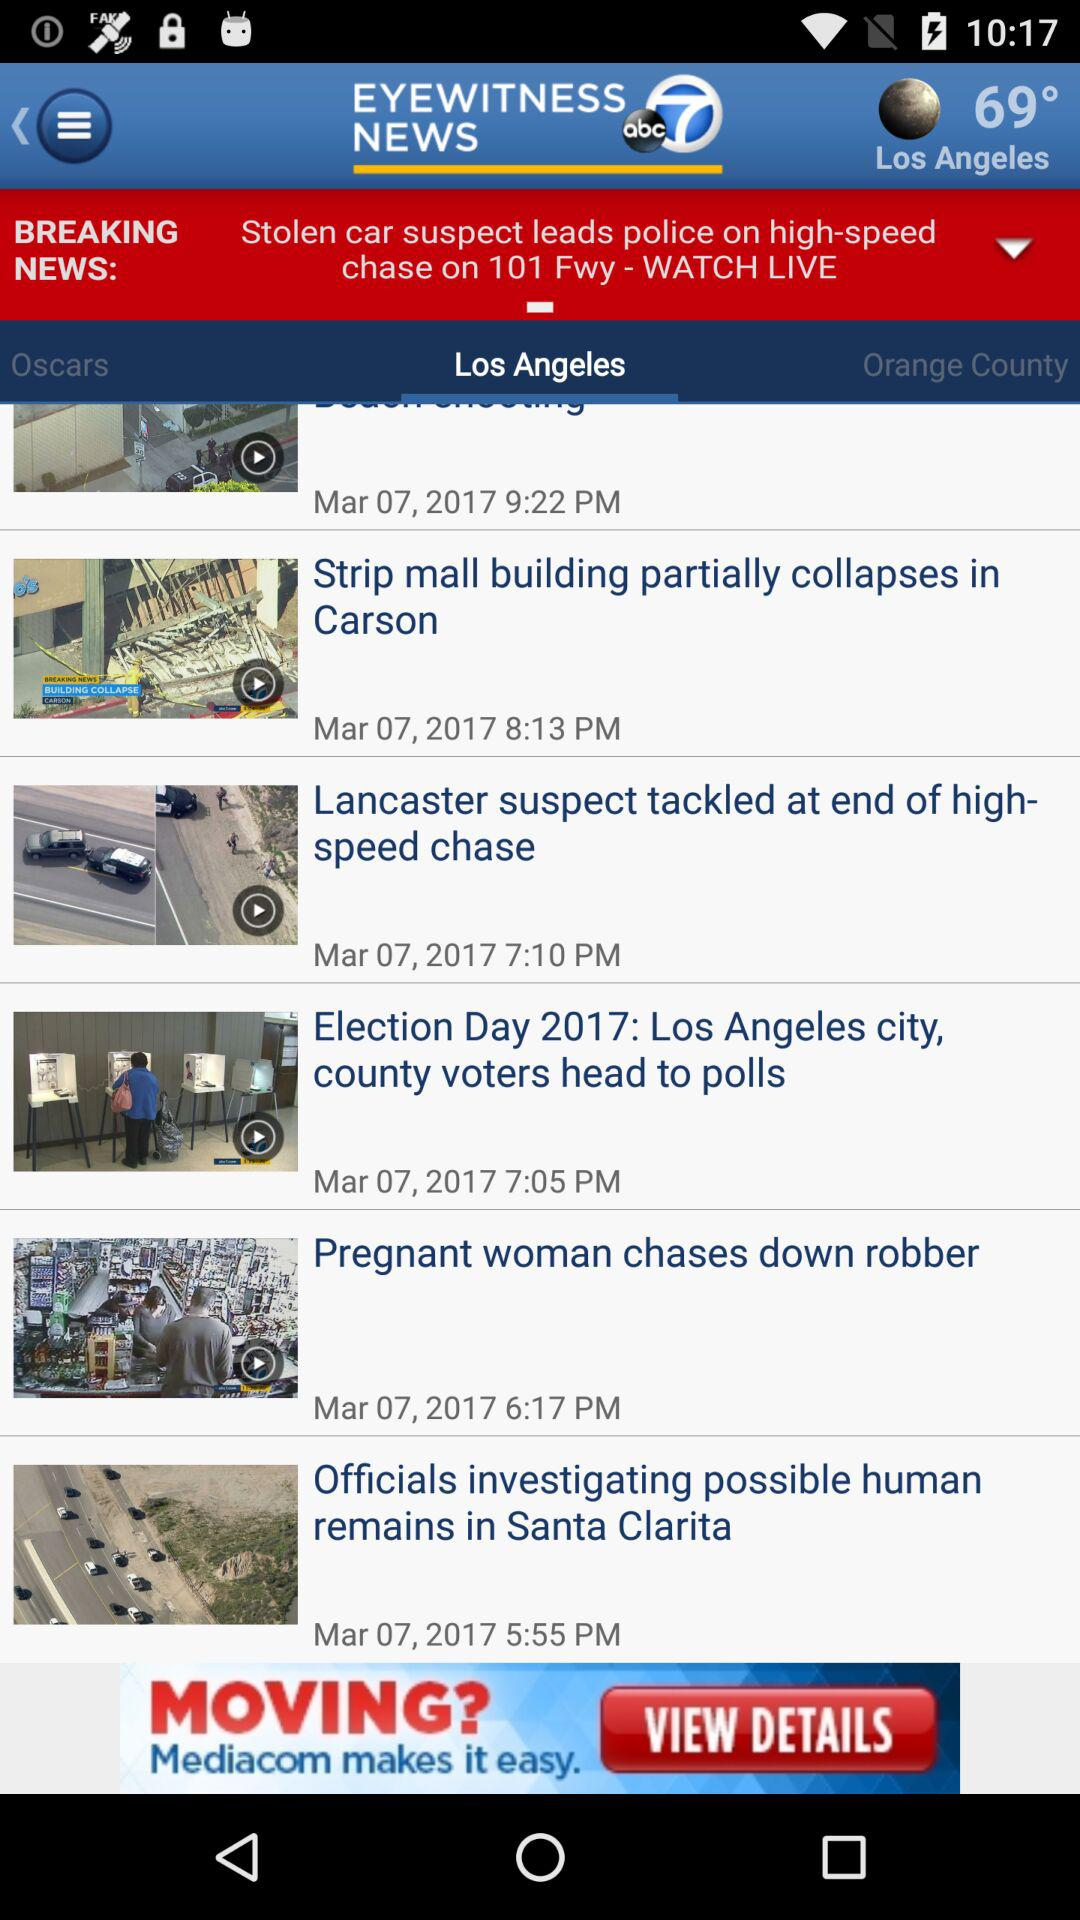What is the time shown in all the posts? The times shown in all the posts are "9:22 PM", "8:13 PM", "7:10 PM", "7:05 PM", "6:17 PM" and "5:55 PM". 